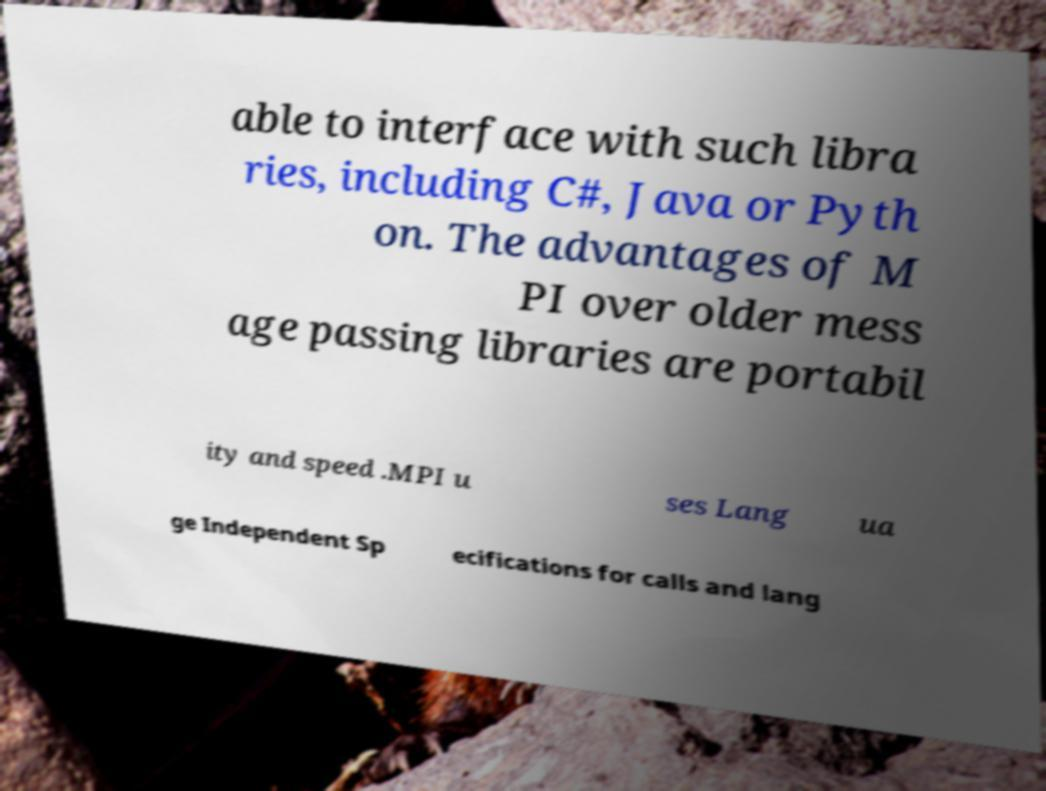What messages or text are displayed in this image? I need them in a readable, typed format. able to interface with such libra ries, including C#, Java or Pyth on. The advantages of M PI over older mess age passing libraries are portabil ity and speed .MPI u ses Lang ua ge Independent Sp ecifications for calls and lang 